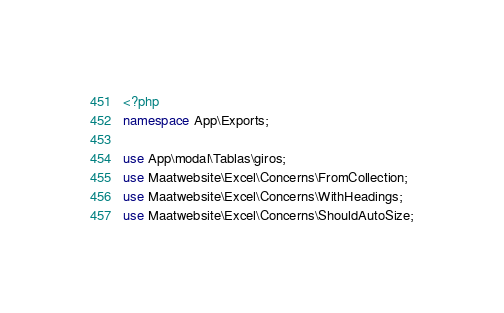<code> <loc_0><loc_0><loc_500><loc_500><_PHP_><?php
namespace App\Exports;

use App\modal\Tablas\giros;
use Maatwebsite\Excel\Concerns\FromCollection;
use Maatwebsite\Excel\Concerns\WithHeadings;
use Maatwebsite\Excel\Concerns\ShouldAutoSize;</code> 